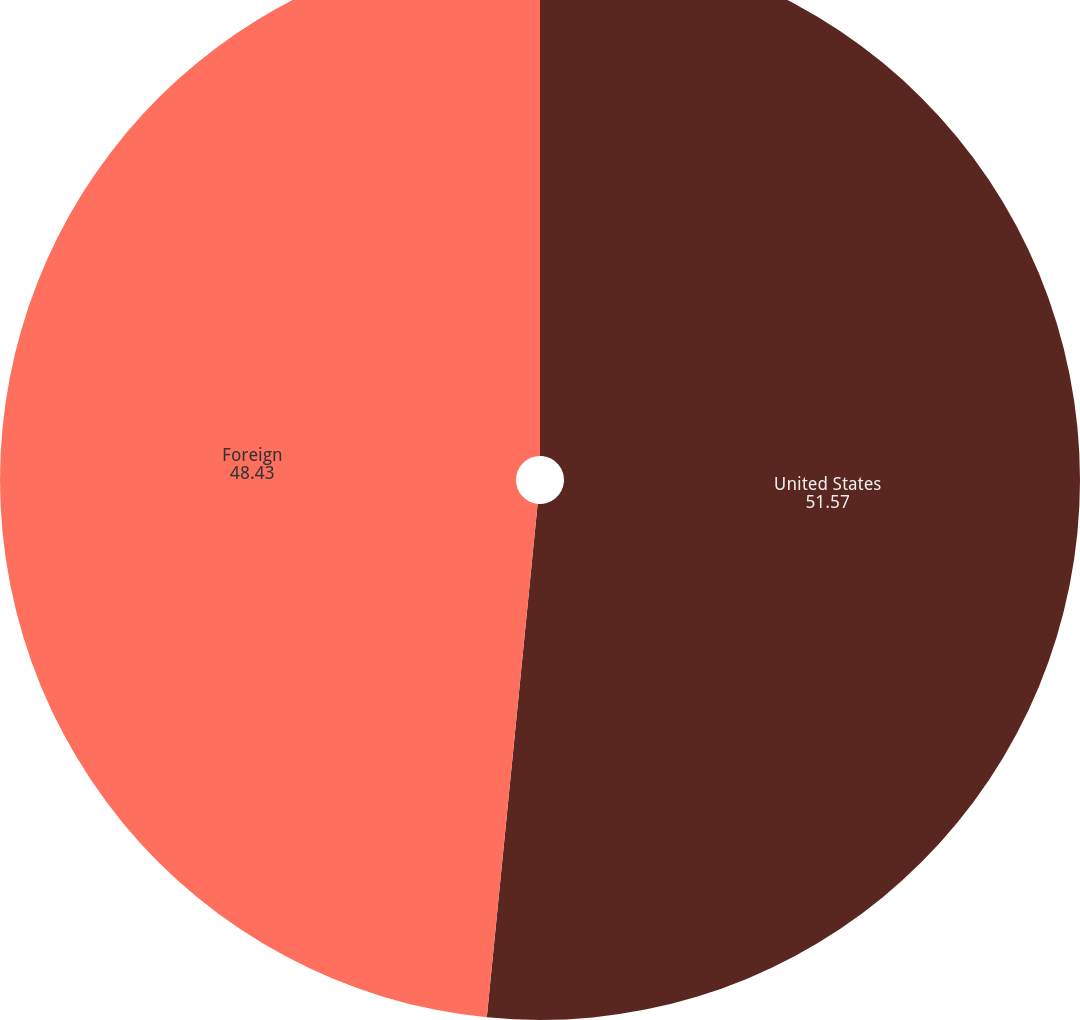<chart> <loc_0><loc_0><loc_500><loc_500><pie_chart><fcel>United States<fcel>Foreign<nl><fcel>51.57%<fcel>48.43%<nl></chart> 